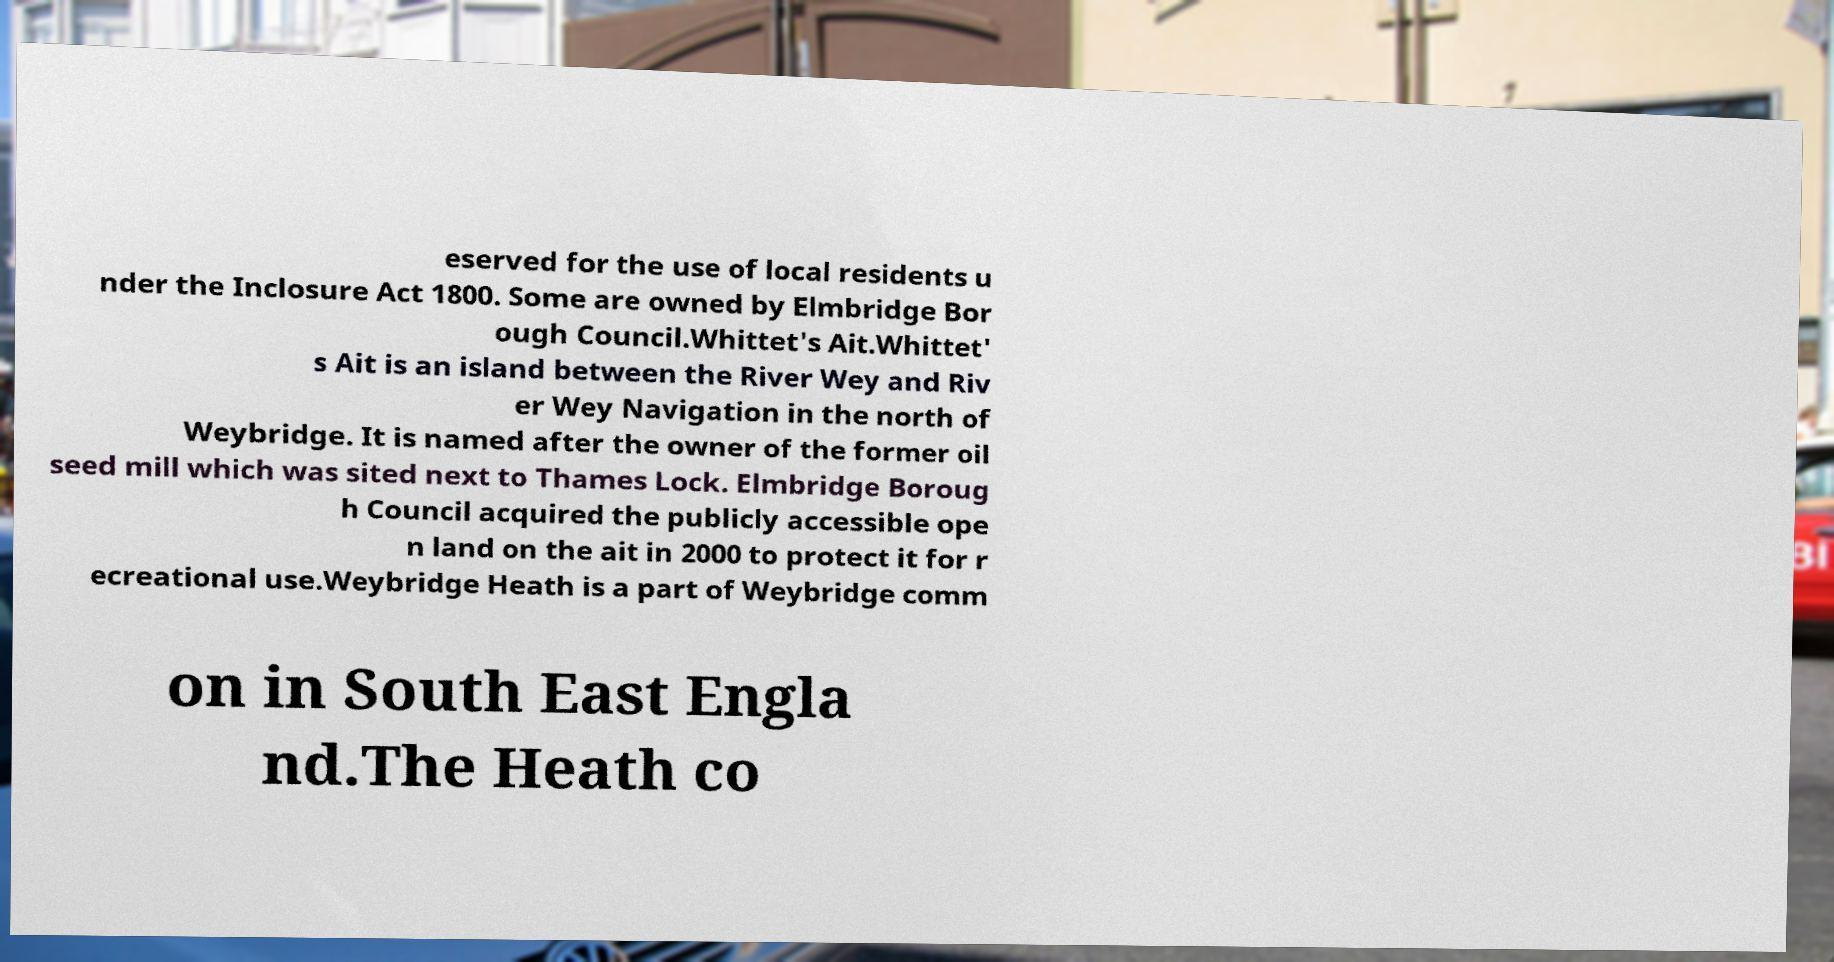Can you accurately transcribe the text from the provided image for me? eserved for the use of local residents u nder the Inclosure Act 1800. Some are owned by Elmbridge Bor ough Council.Whittet's Ait.Whittet' s Ait is an island between the River Wey and Riv er Wey Navigation in the north of Weybridge. It is named after the owner of the former oil seed mill which was sited next to Thames Lock. Elmbridge Boroug h Council acquired the publicly accessible ope n land on the ait in 2000 to protect it for r ecreational use.Weybridge Heath is a part of Weybridge comm on in South East Engla nd.The Heath co 